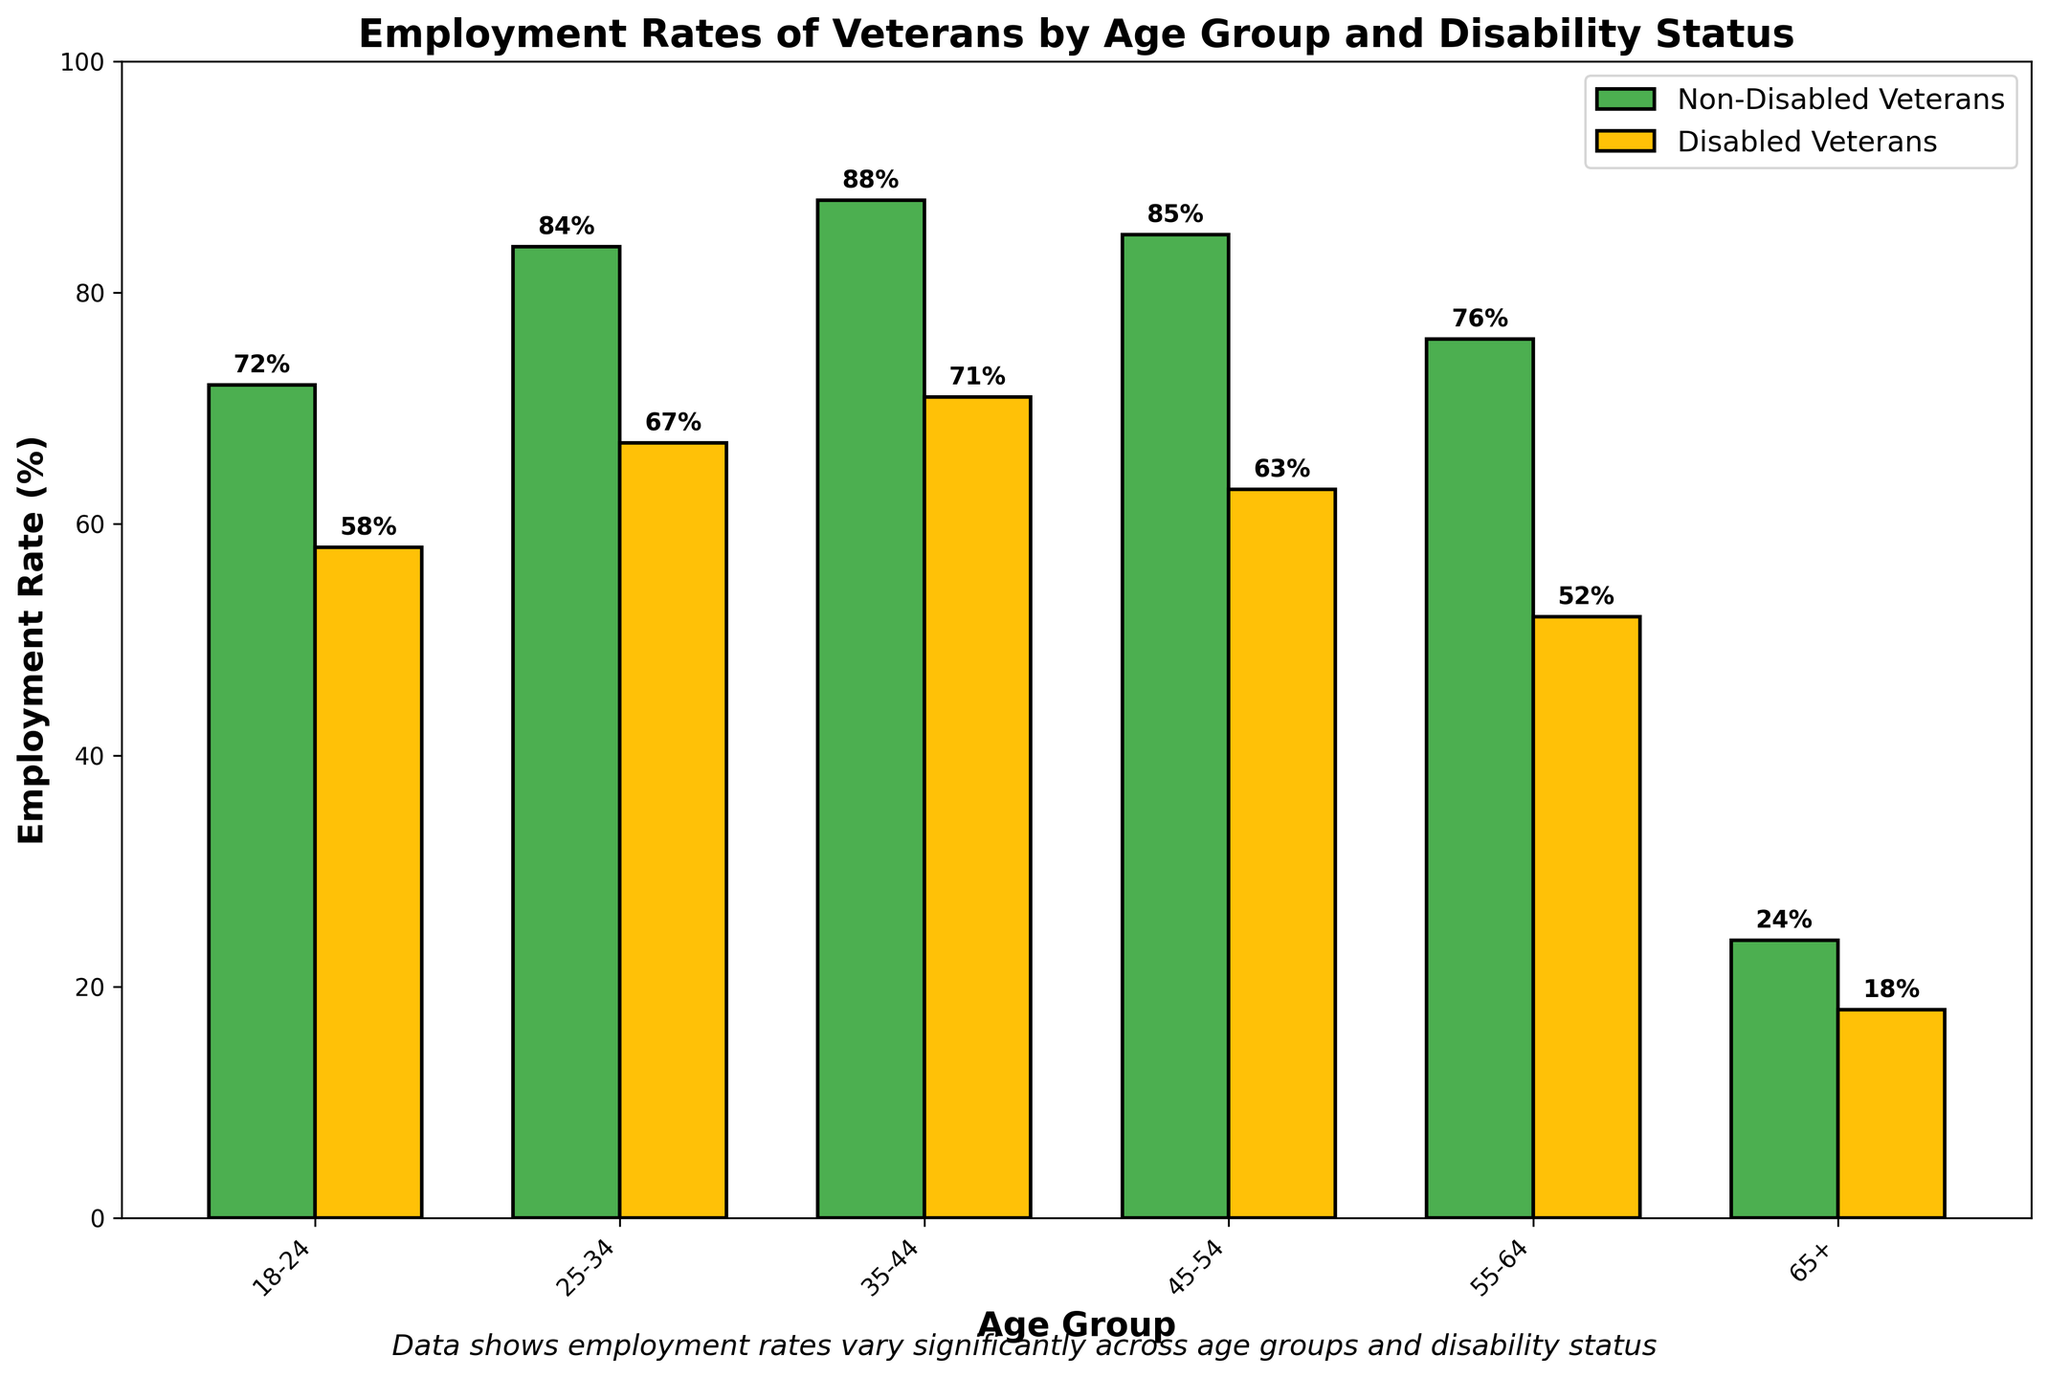What is the employment rate for non-disabled veterans in the 35-44 age group? To find the employment rate for non-disabled veterans in the 35-44 age group, locate the corresponding bar and read the value marked.
Answer: 88% Which age group has the lowest employment rate for disabled veterans? Compare the bars representing disabled veterans across all age groups and identify the one with the lowest height.
Answer: 65+ How much higher is the employment rate for non-disabled veterans aged 25-34 compared to disabled veterans in the same age group? Subtract the employment rate of disabled veterans in the 25-34 group from the employment rate of non-disabled veterans in the same group. 84% - 67% = 17%
Answer: 17% What is the average employment rate for non-disabled veterans across all age groups? Sum the employment rates of non-disabled veterans in all age groups and divide by the number of age groups. (72 + 84 + 88 + 85 + 76 + 24) / 6 = 429 / 6 = 71.5%
Answer: 71.5% Which group has a higher employment rate in the 45-54 age group, and by how much? Compare the employment rates of non-disabled and disabled veterans in the 45-54 age group. Then, calculate the difference. 85% (Non-Disabled) - 63% (Disabled) = 22%
Answer: Non-disabled veterans, 22% What color represents the bars for disabled veterans in the chart? Identify the color used to fill the bars representing disabled veterans.
Answer: Yellow How many age groups have an employment rate of over 70% for both non-disabled and disabled veterans? Count the number of age groups where the employment rates for both non-disabled and disabled veterans exceed 70%.
Answer: 2 Is there any age group where the employment rate for non-disabled veterans is less than 50%? Check all the age groups and see if any non-disabled veteran group’s employment rate is below 50%.
Answer: Yes (65+) Which age group shows the largest difference in employment rates between non-disabled and disabled veterans? Calculate the difference between employment rates for non-disabled and disabled veterans for each age group and identify the maximum. 14% (18-24), 17% (25-34), 17% (35-44), 22% (45-54), 24% (55-64), 6% (65+) = 24% (55-64)
Answer: 55-64 